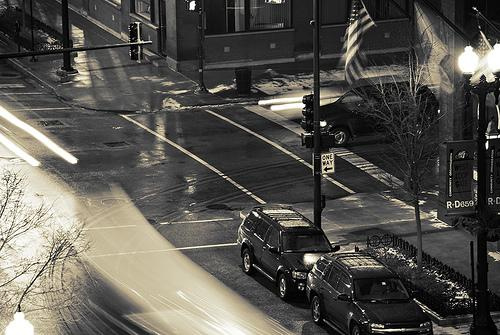What flag can be seen here? Please explain your reasoning. united states. The flag has stars on the side. 